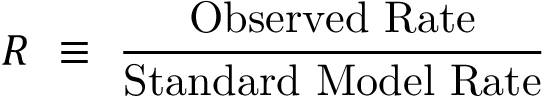<formula> <loc_0><loc_0><loc_500><loc_500>R \equiv \frac { O b s e r v e d R a t e } { S t a n d a r d M o d e l R a t e }</formula> 